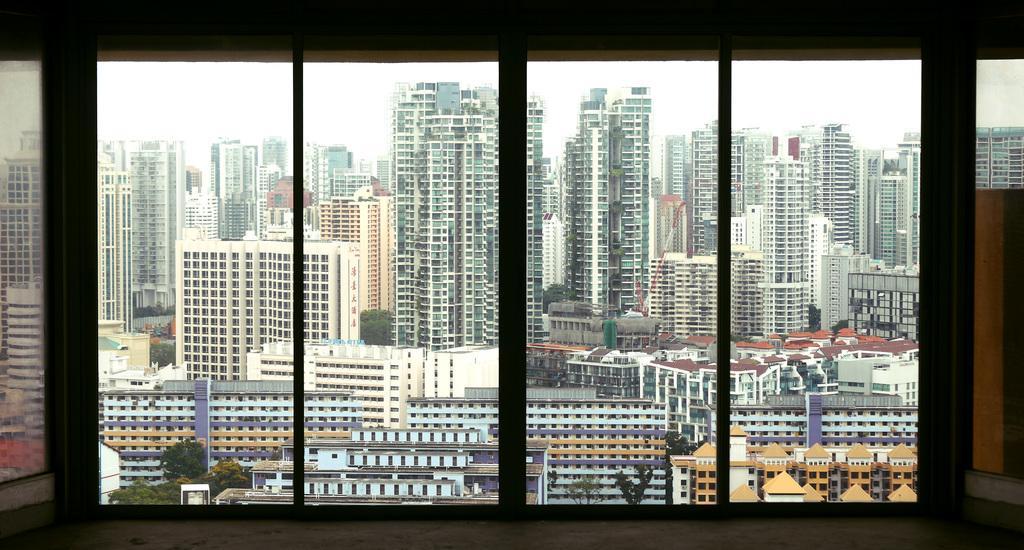Could you give a brief overview of what you see in this image? In this image we can see a group of buildings, housing, a crane, some trees and the sky. In the foreground we can see a window. 